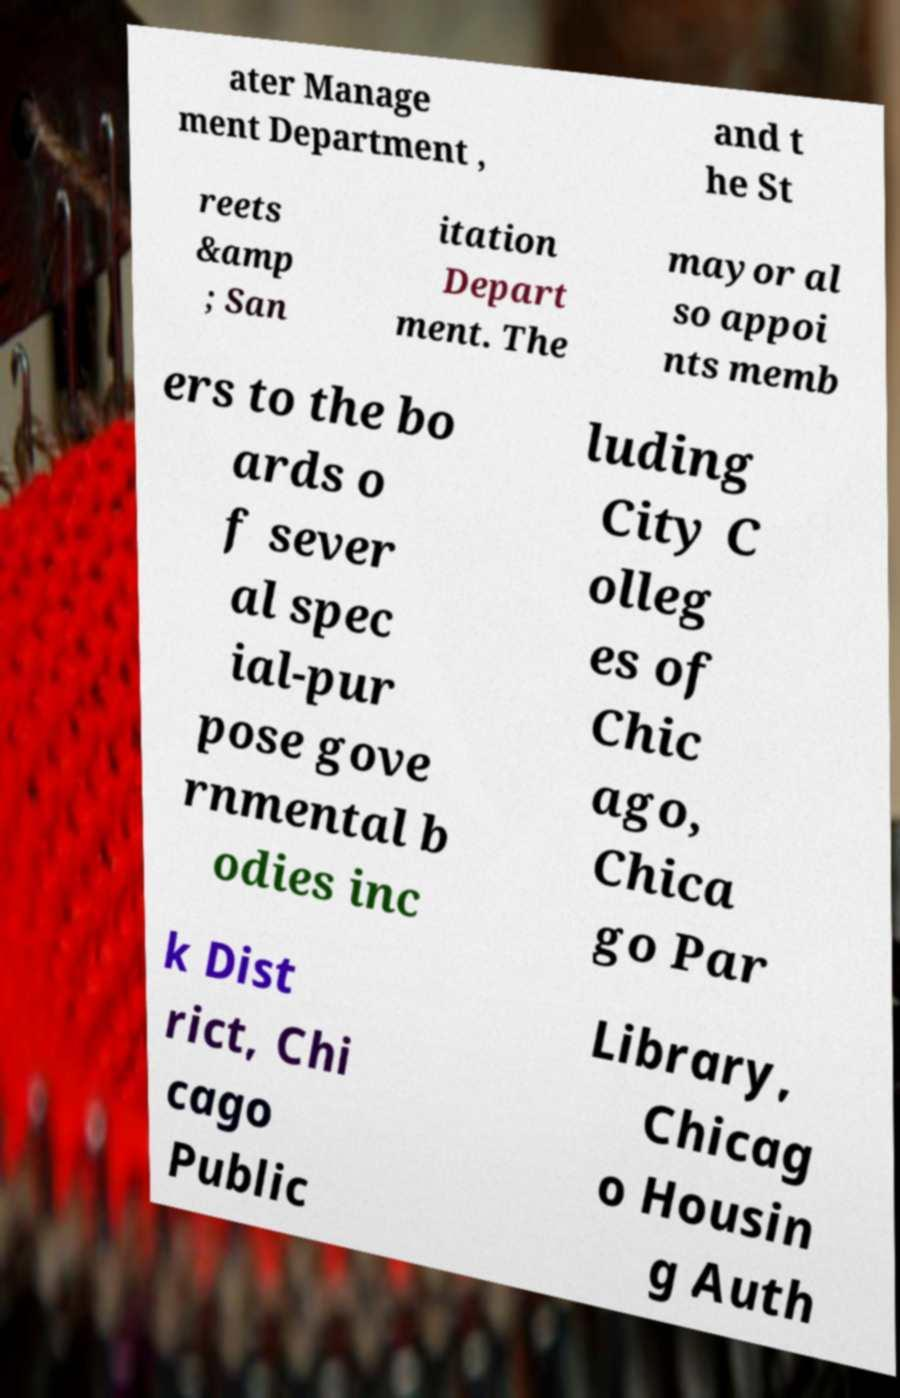Can you accurately transcribe the text from the provided image for me? ater Manage ment Department , and t he St reets &amp ; San itation Depart ment. The mayor al so appoi nts memb ers to the bo ards o f sever al spec ial-pur pose gove rnmental b odies inc luding City C olleg es of Chic ago, Chica go Par k Dist rict, Chi cago Public Library, Chicag o Housin g Auth 